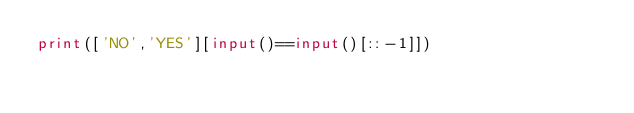<code> <loc_0><loc_0><loc_500><loc_500><_Python_>print(['NO','YES'][input()==input()[::-1]])</code> 